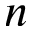Convert formula to latex. <formula><loc_0><loc_0><loc_500><loc_500>n</formula> 